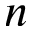Convert formula to latex. <formula><loc_0><loc_0><loc_500><loc_500>n</formula> 